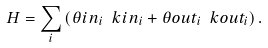<formula> <loc_0><loc_0><loc_500><loc_500>H = \sum _ { i } \left ( \theta i n _ { i } \ k i n _ { i } + \theta o u t _ { i } \ k o u t _ { i } \right ) .</formula> 